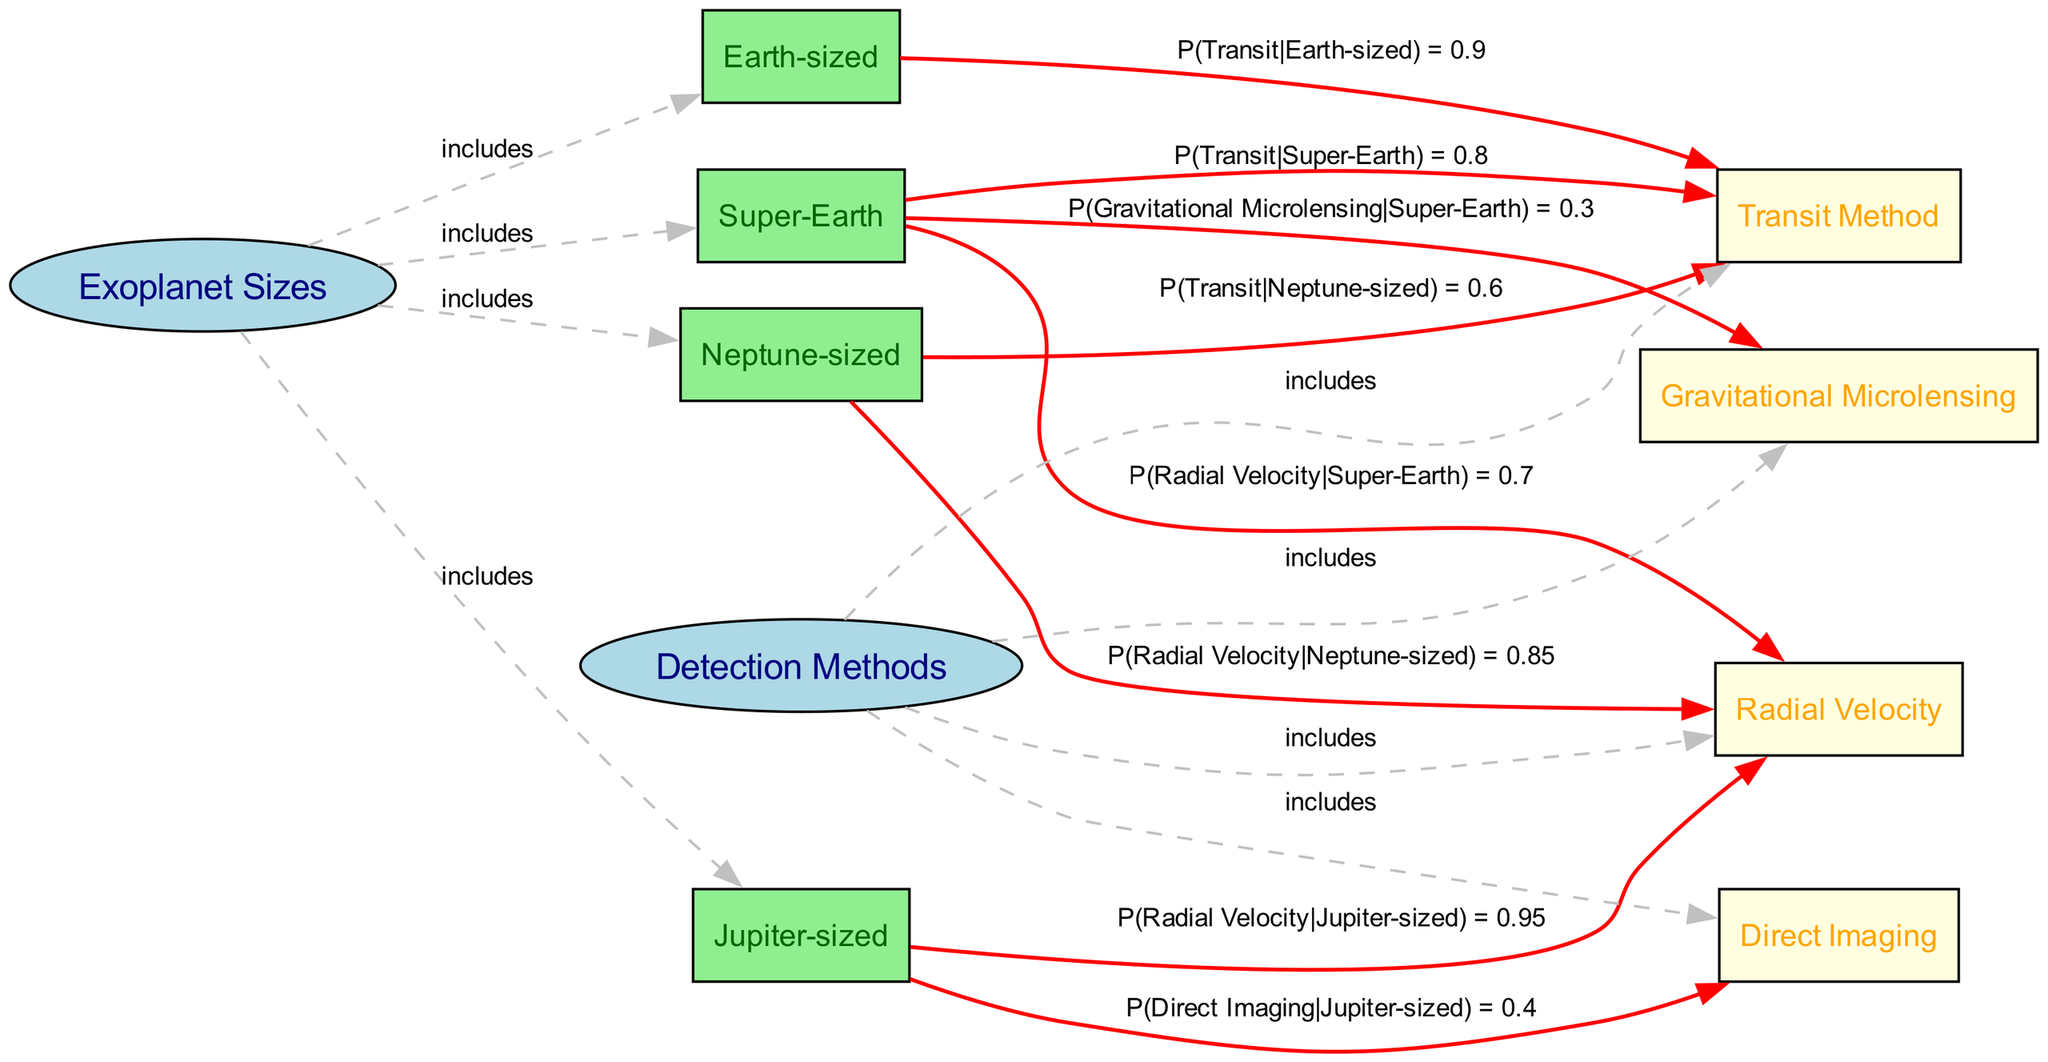What are the sizes of the exoplanets illustrated? The diagram shows four sizes of exoplanets: Earth-sized, Super-Earth, Neptune-sized, and Jupiter-sized. These are labeled as exoplanet size nodes connected to the central Exoplanet Sizes node.
Answer: Earth-sized, Super-Earth, Neptune-sized, Jupiter-sized Which detection method has the highest conditional probability for Earth-sized exoplanets? The diagram indicates that the Transit Method has a probability of 0.9 for Earth-sized exoplanets, which is the highest conditional probability among the methods shown.
Answer: Transit Method How many detection methods are shown in the diagram? The diagram includes four detection methods: Transit Method, Radial Velocity, Direct Imaging, and Gravitational Microlensing.
Answer: Four What is the probability of detecting a Super-Earth using the Radial Velocity method? The diagram specifies that the conditional probability of using the Radial Velocity method for Super-Earth exoplanets is 0.7, as indicated by the edge connecting Super-Earth to Radial Velocity.
Answer: 0.7 Which size of exoplanet has the lowest conditional probability for detection using the Transit Method? The Neptune-sized exoplanet has the lowest conditional probability for detection using the Transit Method at 0.6, compared to the other sizes depicted in the diagram.
Answer: Neptune-sized 